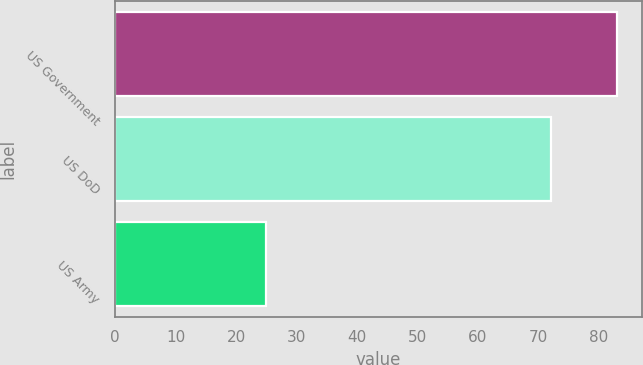Convert chart. <chart><loc_0><loc_0><loc_500><loc_500><bar_chart><fcel>US Government<fcel>US DoD<fcel>US Army<nl><fcel>83<fcel>72<fcel>25<nl></chart> 